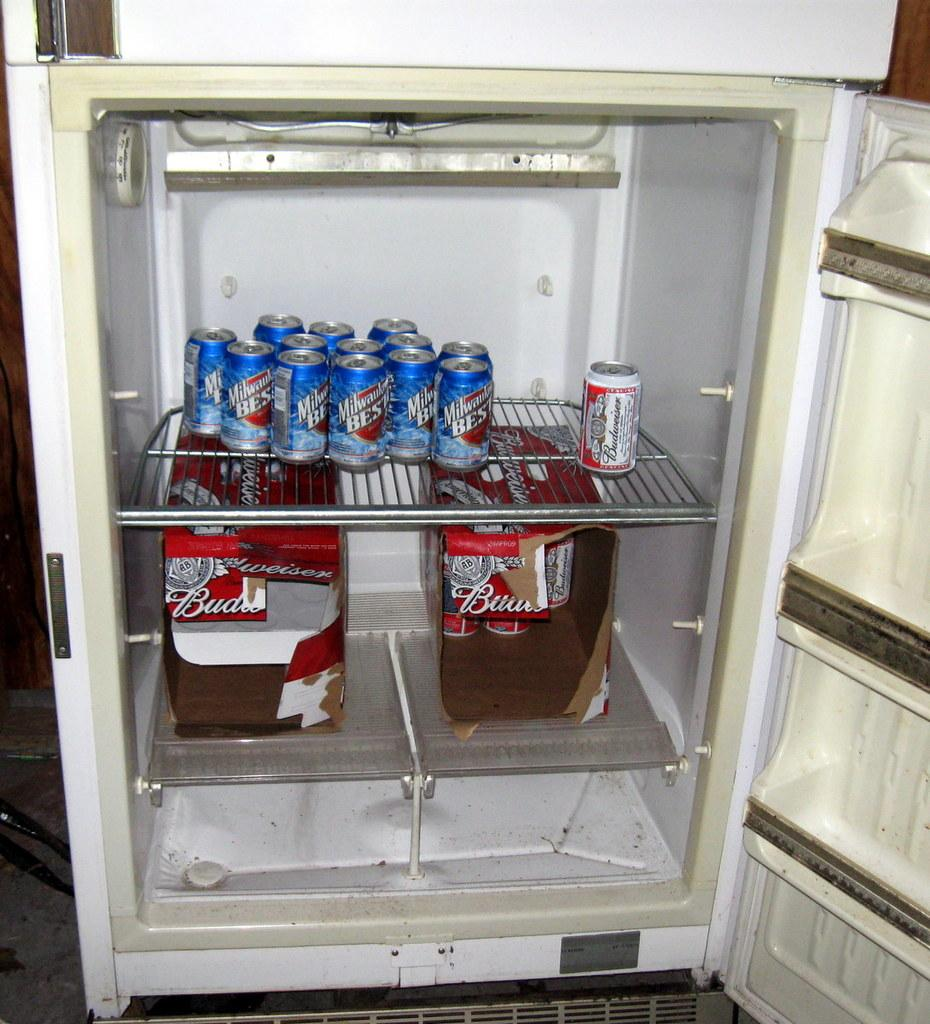<image>
Render a clear and concise summary of the photo. An open refrigerator that contains cans of Milwaukee's Best and Budweiser beer. 